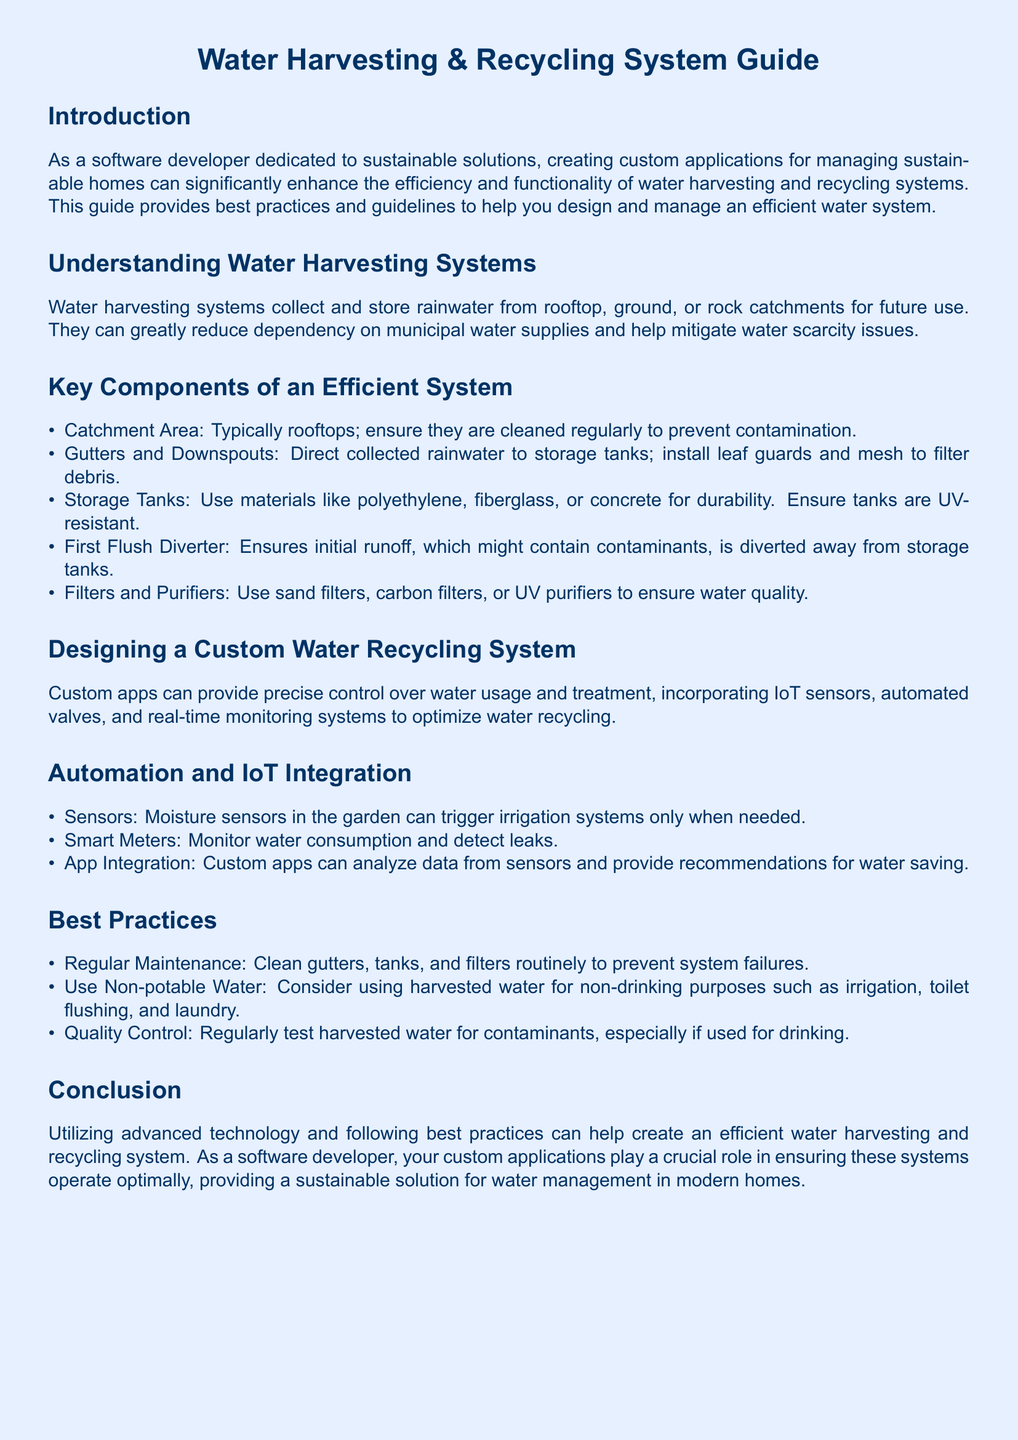What is the main purpose of the guide? The guide aims to provide best practices and guidelines to help design and manage an efficient water system.
Answer: Efficient water system What materials are recommended for storage tanks? The document lists polyethylene, fiberglass, or concrete as durable materials for storage tanks.
Answer: Polyethylene, fiberglass, or concrete What should be used to divert initial runoff? A first flush diverter is used to divert the initial runoff that might contain contaminants.
Answer: First flush diverter What is a key feature of IoT integration in water management? Smart meters are used to monitor water consumption and detect leaks as part of IoT integration.
Answer: Smart meters How often should system components be cleaned? The best practice suggests regular maintenance, indicating routine cleaning should be performed.
Answer: Regularly What is the function of filters and purifiers in the system? Filters and purifiers aim to ensure water quality by removing contaminants from harvested water.
Answer: Ensure water quality Name an example of non-potable water use mentioned in the guide. The guide mentions using harvested water for irrigation, toilet flushing, and laundry as examples of non-potable usage.
Answer: Irrigation What innovative feature can custom apps provide for water recycling? Custom apps can provide precise control over water usage and treatment in water recycling systems.
Answer: Precise control What should be tested regularly in harvested water? Harvested water should be regularly tested for contaminants, especially if used for drinking purposes.
Answer: Contaminants 